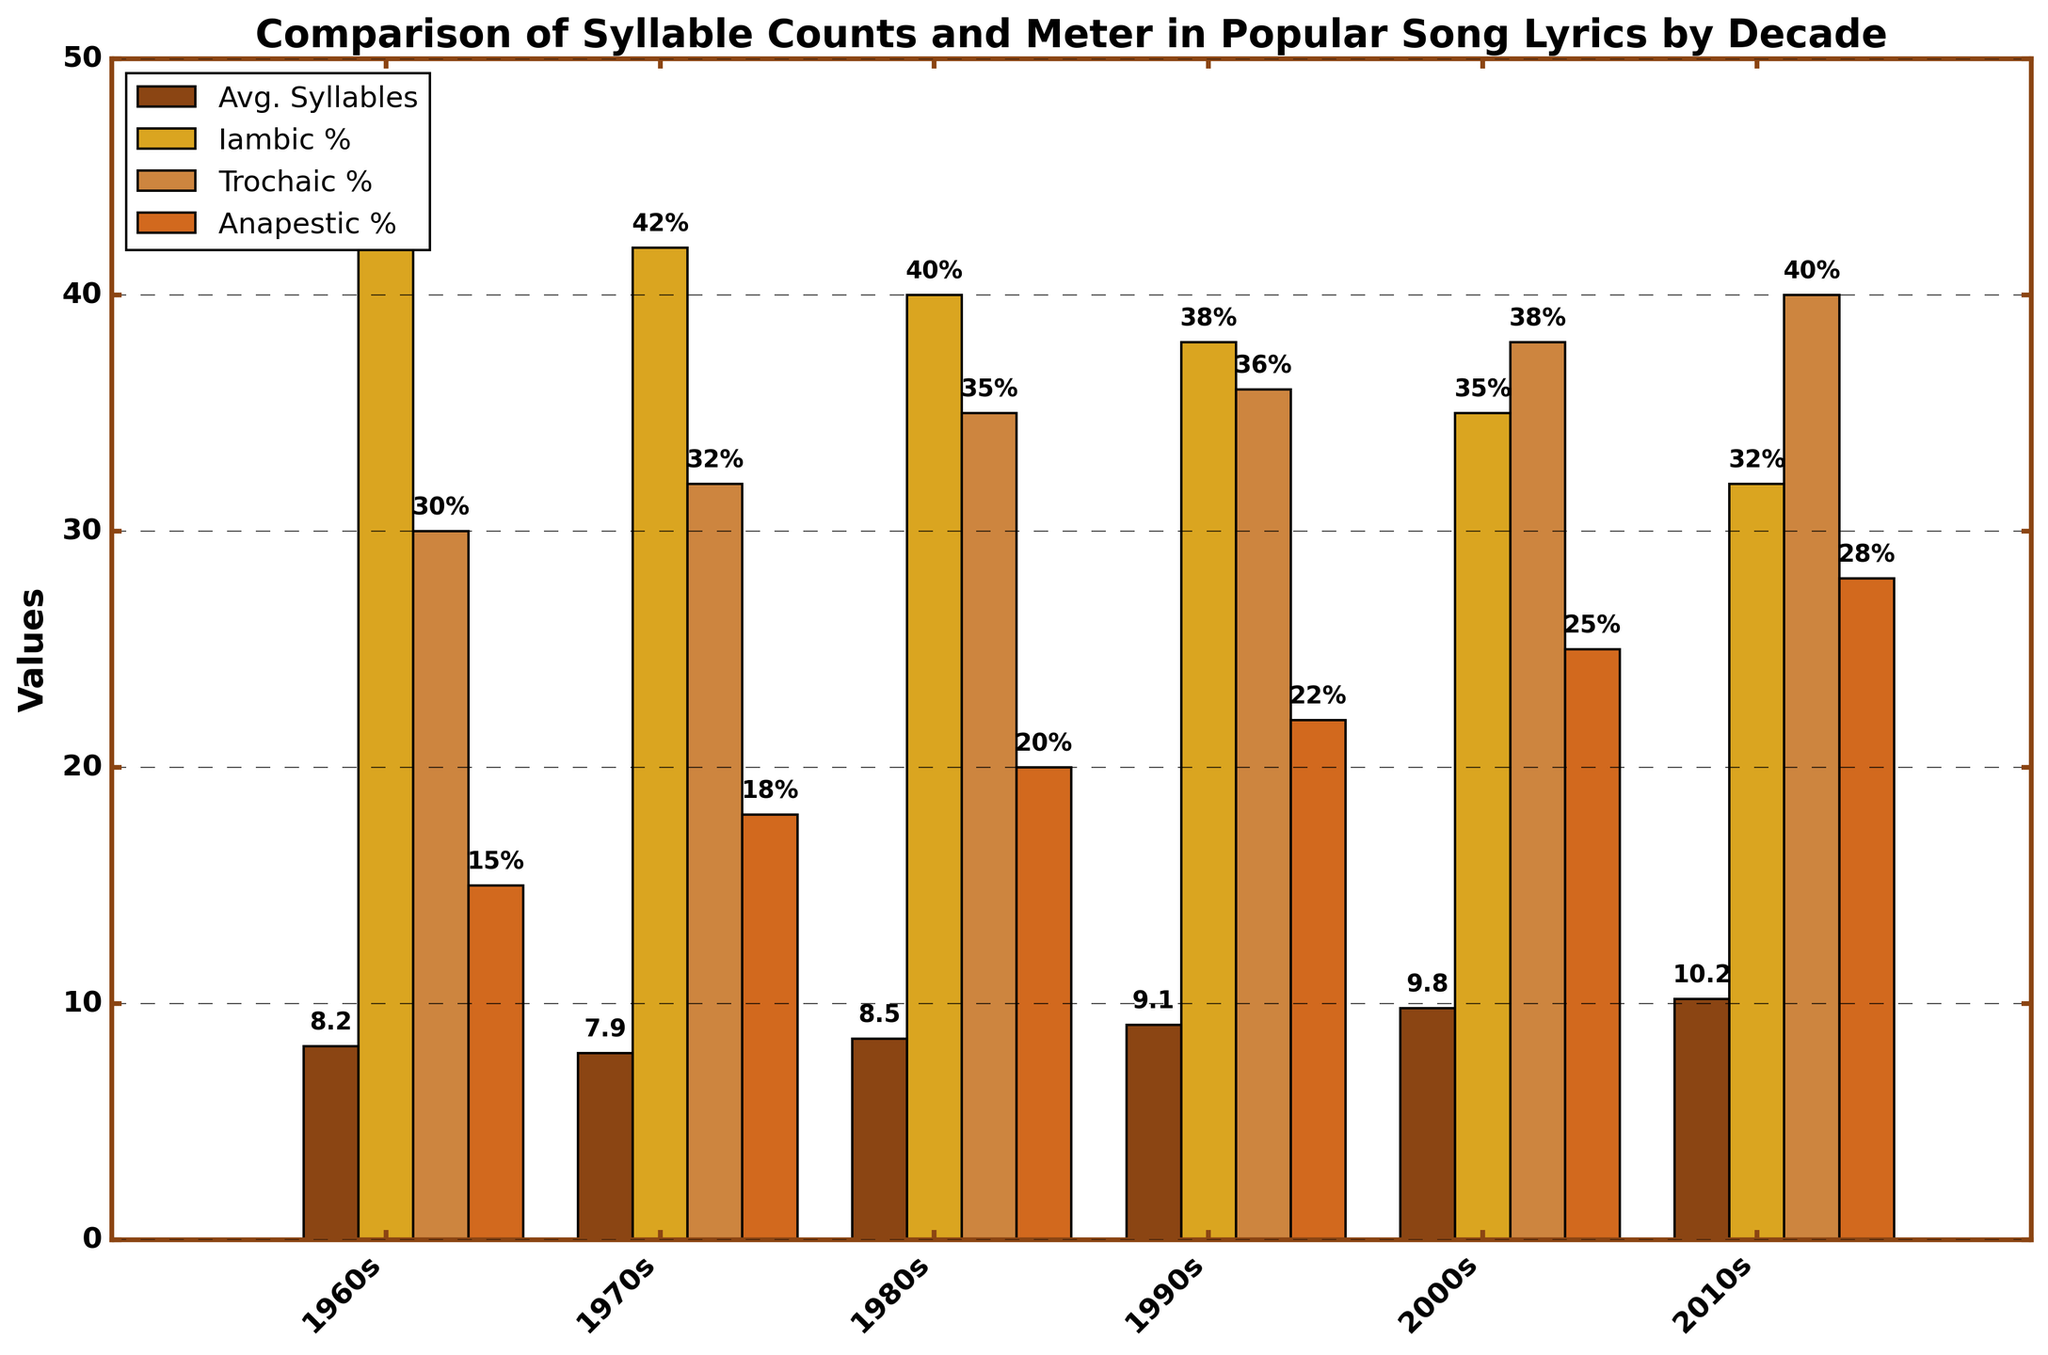What trend can you observe in the average syllables per line from the 1960s to the 2010s? Observe the heights of the bars labeled "Avg. Syllables" for each decade: from the 1960s to the 2010s, the bar heights increase consistently.
Answer: Increasing trend Which decade had the highest percentage of Iambic meter in popular song lyrics? Look for the tallest "Iambic %" bar. Among the given decades, the 1960s bar is the tallest for Iambic percentage.
Answer: 1960s How does the percentage of Trochaic meter in the 2010s compare to that in the 1960s? Compare the height of the Trochaic bar for the 2010s to the one in the 1960s. The 2010s has a higher Trochaic percentage bar than the 1960s.
Answer: Higher in 2010s In which decade do we see the least usage of Anapestic meter? Identify the shortest "Anapestic %" bar. The 1960s bar for Anapestic percentage is the shortest.
Answer: 1960s From the 1960s to the 2010s, which meter shows a decreasing trend in its percentage? Compare the heights of the bars for each meter across the decades: Iambic percentage decreases consistently from the 1960s to the 2010s.
Answer: Iambic What is the percentage difference in Trochaic meter between the 2000s and 1970s? Calculate the difference between the Trochaic percentages for the 2000s and 1970s: 38% (2000s) - 32% (1970s).
Answer: 6% Which meter type became more prevalent from the 1980s to the 2000s based on the percentage values? Compare the changes in the bar heights from the 1980s to the 2000s for each meter: Anapestic percentage shows the most significant increase.
Answer: Anapestic How much did the average syllables per line increase from the 1960s to the 2010s? Subtract the average syllables per line in the 1960s from that in the 2010s: 10.2 - 8.2.
Answer: 2 In the 1990s, which meter type had the highest percentage? Find the tallest bar for each meter type in the 1990s. The Trochaic percentage bar is the highest.
Answer: Trochaic 